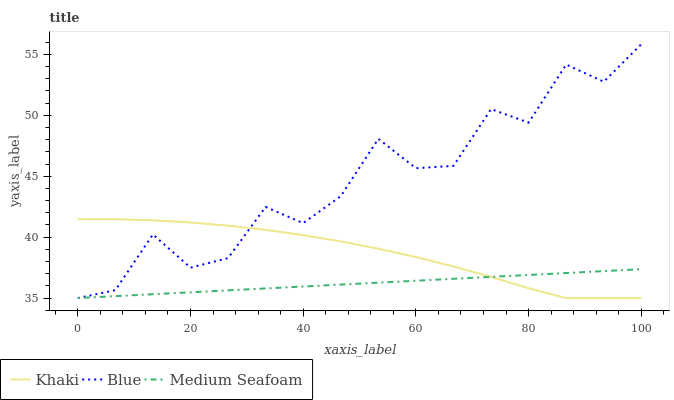Does Medium Seafoam have the minimum area under the curve?
Answer yes or no. Yes. Does Blue have the maximum area under the curve?
Answer yes or no. Yes. Does Khaki have the minimum area under the curve?
Answer yes or no. No. Does Khaki have the maximum area under the curve?
Answer yes or no. No. Is Medium Seafoam the smoothest?
Answer yes or no. Yes. Is Blue the roughest?
Answer yes or no. Yes. Is Khaki the smoothest?
Answer yes or no. No. Is Khaki the roughest?
Answer yes or no. No. Does Blue have the lowest value?
Answer yes or no. Yes. Does Blue have the highest value?
Answer yes or no. Yes. Does Khaki have the highest value?
Answer yes or no. No. Does Medium Seafoam intersect Khaki?
Answer yes or no. Yes. Is Medium Seafoam less than Khaki?
Answer yes or no. No. Is Medium Seafoam greater than Khaki?
Answer yes or no. No. 